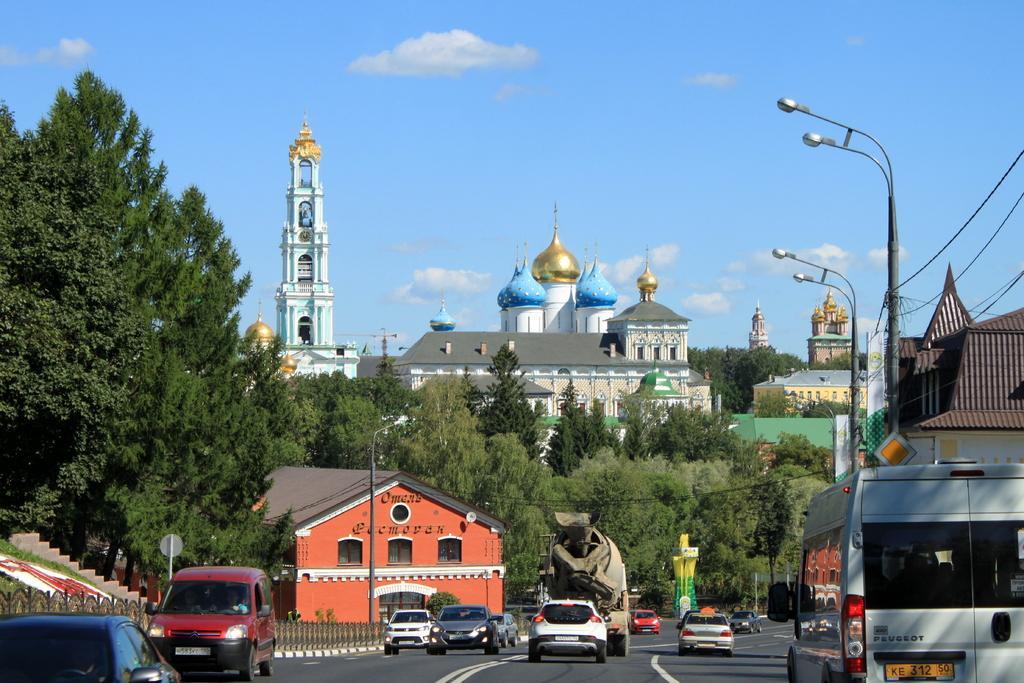Could you give a brief overview of what you see in this image? In this image, we can see so many trees, buildings, street lights, wires, poles, boards, stairs, grills. At the bottom, we can see vehicles are moving on the road. Background there is a sky. 